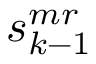Convert formula to latex. <formula><loc_0><loc_0><loc_500><loc_500>s _ { k - 1 } ^ { m r }</formula> 